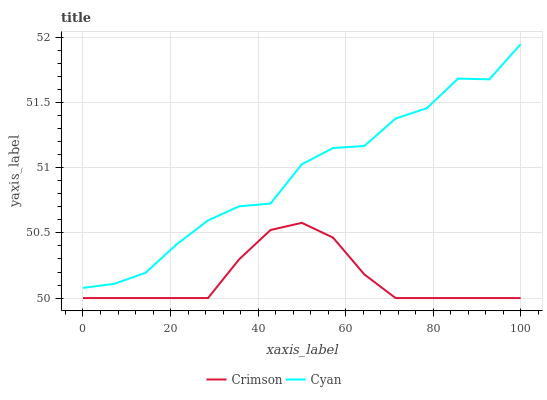Does Crimson have the minimum area under the curve?
Answer yes or no. Yes. Does Cyan have the maximum area under the curve?
Answer yes or no. Yes. Does Cyan have the minimum area under the curve?
Answer yes or no. No. Is Crimson the smoothest?
Answer yes or no. Yes. Is Cyan the roughest?
Answer yes or no. Yes. Is Cyan the smoothest?
Answer yes or no. No. Does Crimson have the lowest value?
Answer yes or no. Yes. Does Cyan have the lowest value?
Answer yes or no. No. Does Cyan have the highest value?
Answer yes or no. Yes. Is Crimson less than Cyan?
Answer yes or no. Yes. Is Cyan greater than Crimson?
Answer yes or no. Yes. Does Crimson intersect Cyan?
Answer yes or no. No. 